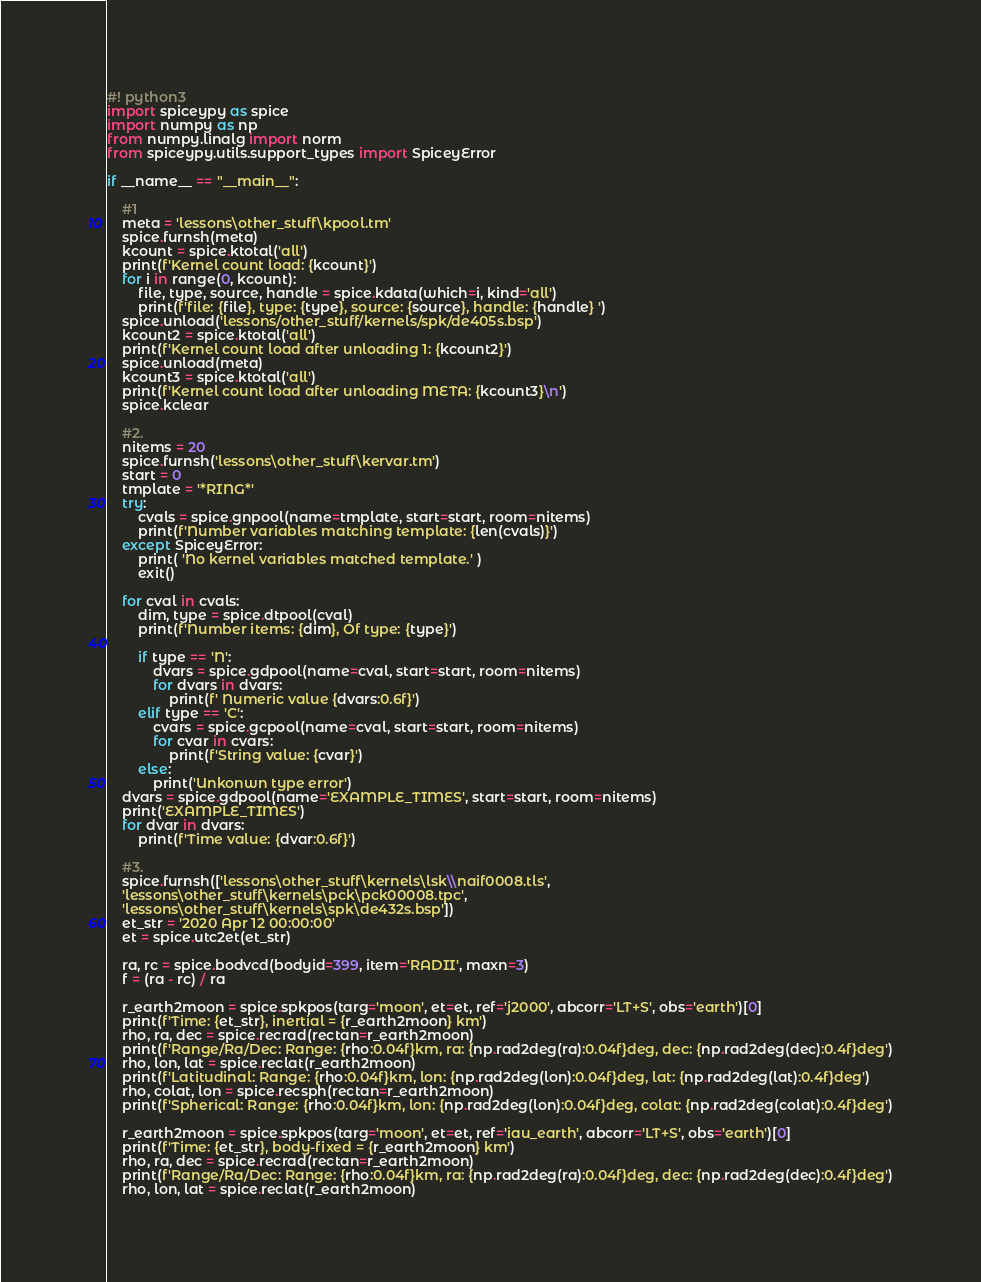<code> <loc_0><loc_0><loc_500><loc_500><_Python_>#! python3
import spiceypy as spice
import numpy as np
from numpy.linalg import norm
from spiceypy.utils.support_types import SpiceyError

if __name__ == "__main__":

    #1
    meta = 'lessons\other_stuff\kpool.tm'
    spice.furnsh(meta)
    kcount = spice.ktotal('all')
    print(f'Kernel count load: {kcount}')
    for i in range(0, kcount):
        file, type, source, handle = spice.kdata(which=i, kind='all')
        print(f'file: {file}, type: {type}, source: {source}, handle: {handle} ')
    spice.unload('lessons/other_stuff/kernels/spk/de405s.bsp')
    kcount2 = spice.ktotal('all')
    print(f'Kernel count load after unloading 1: {kcount2}')
    spice.unload(meta)
    kcount3 = spice.ktotal('all')
    print(f'Kernel count load after unloading META: {kcount3}\n')
    spice.kclear

    #2.
    nitems = 20
    spice.furnsh('lessons\other_stuff\kervar.tm')
    start = 0
    tmplate = '*RING*'
    try:
        cvals = spice.gnpool(name=tmplate, start=start, room=nitems)
        print(f'Number variables matching template: {len(cvals)}')
    except SpiceyError:
        print( 'No kernel variables matched template.' )
        exit()
    
    for cval in cvals:
        dim, type = spice.dtpool(cval)
        print(f'Number items: {dim}, Of type: {type}')

        if type == 'N':
            dvars = spice.gdpool(name=cval, start=start, room=nitems)
            for dvars in dvars:
                print(f' Numeric value {dvars:0.6f}')
        elif type == 'C':
            cvars = spice.gcpool(name=cval, start=start, room=nitems)
            for cvar in cvars:
                print(f'String value: {cvar}')
        else:
            print('Unkonwn type error')
    dvars = spice.gdpool(name='EXAMPLE_TIMES', start=start, room=nitems)
    print('EXAMPLE_TIMES')
    for dvar in dvars:
        print(f'Time value: {dvar:0.6f}')

    #3.
    spice.furnsh(['lessons\other_stuff\kernels\lsk\\naif0008.tls',
    'lessons\other_stuff\kernels\pck\pck00008.tpc',
    'lessons\other_stuff\kernels\spk\de432s.bsp'])
    et_str = '2020 Apr 12 00:00:00'
    et = spice.utc2et(et_str)
    
    ra, rc = spice.bodvcd(bodyid=399, item='RADII', maxn=3)
    f = (ra - rc) / ra

    r_earth2moon = spice.spkpos(targ='moon', et=et, ref='j2000', abcorr='LT+S', obs='earth')[0]
    print(f'Time: {et_str}, inertial = {r_earth2moon} km')
    rho, ra, dec = spice.recrad(rectan=r_earth2moon)
    print(f'Range/Ra/Dec: Range: {rho:0.04f}km, ra: {np.rad2deg(ra):0.04f}deg, dec: {np.rad2deg(dec):0.4f}deg')
    rho, lon, lat = spice.reclat(r_earth2moon)
    print(f'Latitudinal: Range: {rho:0.04f}km, lon: {np.rad2deg(lon):0.04f}deg, lat: {np.rad2deg(lat):0.4f}deg')
    rho, colat, lon = spice.recsph(rectan=r_earth2moon)
    print(f'Spherical: Range: {rho:0.04f}km, lon: {np.rad2deg(lon):0.04f}deg, colat: {np.rad2deg(colat):0.4f}deg')

    r_earth2moon = spice.spkpos(targ='moon', et=et, ref='iau_earth', abcorr='LT+S', obs='earth')[0]
    print(f'Time: {et_str}, body-fixed = {r_earth2moon} km')
    rho, ra, dec = spice.recrad(rectan=r_earth2moon)
    print(f'Range/Ra/Dec: Range: {rho:0.04f}km, ra: {np.rad2deg(ra):0.04f}deg, dec: {np.rad2deg(dec):0.4f}deg')
    rho, lon, lat = spice.reclat(r_earth2moon)</code> 